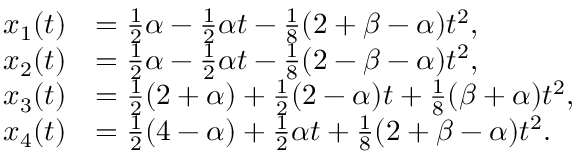Convert formula to latex. <formula><loc_0><loc_0><loc_500><loc_500>\begin{array} { r l } { x _ { 1 } ( t ) } & { = \frac { 1 } { 2 } \alpha - \frac { 1 } { 2 } \alpha t - \frac { 1 } { 8 } ( 2 + \beta - \alpha ) t ^ { 2 } , } \\ { x _ { 2 } ( t ) } & { = \frac { 1 } { 2 } \alpha - \frac { 1 } { 2 } \alpha t - \frac { 1 } { 8 } ( 2 - \beta - \alpha ) t ^ { 2 } , } \\ { x _ { 3 } ( t ) } & { = \frac { 1 } { 2 } ( 2 + \alpha ) + \frac { 1 } { 2 } ( 2 - \alpha ) t + \frac { 1 } { 8 } ( \beta + \alpha ) t ^ { 2 } , } \\ { x _ { 4 } ( t ) } & { = \frac { 1 } { 2 } ( 4 - \alpha ) + \frac { 1 } { 2 } \alpha t + \frac { 1 } { 8 } ( 2 + \beta - \alpha ) t ^ { 2 } . } \end{array}</formula> 